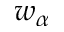Convert formula to latex. <formula><loc_0><loc_0><loc_500><loc_500>w _ { \alpha }</formula> 